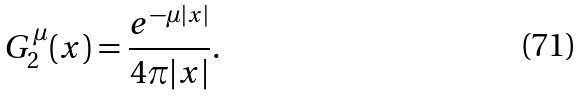Convert formula to latex. <formula><loc_0><loc_0><loc_500><loc_500>G ^ { \mu } _ { 2 } ( x ) = \frac { e ^ { - \mu | x | } } { 4 \pi | x | } .</formula> 